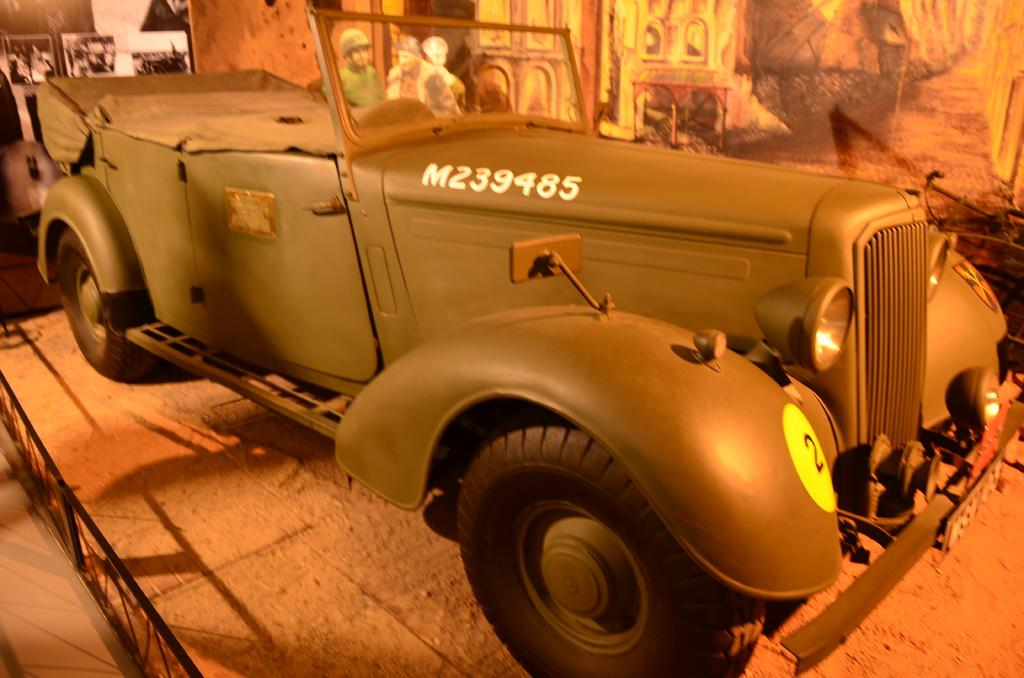What is the main subject in the center of the image? There is a vehicle in the center of the image. Can you describe the people in the image? There are people in the image, but their specific actions or positions are not mentioned in the facts. What can be seen in the background of the image? There are boards visible in the background of the image. What type of apples are being sold by the lawyer in the image? There is no mention of apples or a lawyer in the image, so this question cannot be answered definitively. 